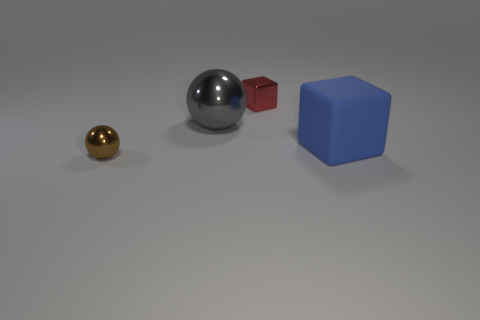Add 2 tiny green spheres. How many objects exist? 6 Subtract all brown balls. How many balls are left? 1 Subtract all gray metallic objects. Subtract all yellow objects. How many objects are left? 3 Add 1 blocks. How many blocks are left? 3 Add 4 red things. How many red things exist? 5 Subtract 0 brown cubes. How many objects are left? 4 Subtract 2 cubes. How many cubes are left? 0 Subtract all yellow blocks. Subtract all red balls. How many blocks are left? 2 Subtract all yellow spheres. How many yellow cubes are left? 0 